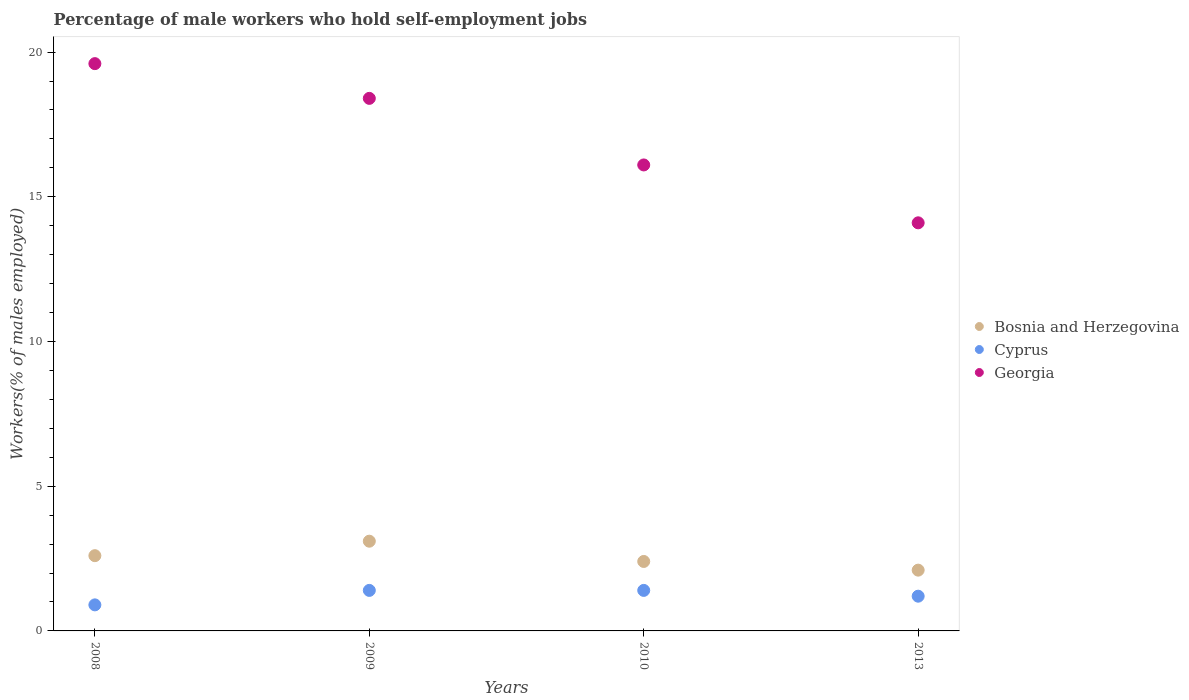How many different coloured dotlines are there?
Keep it short and to the point. 3. What is the percentage of self-employed male workers in Georgia in 2013?
Provide a short and direct response. 14.1. Across all years, what is the maximum percentage of self-employed male workers in Bosnia and Herzegovina?
Offer a terse response. 3.1. Across all years, what is the minimum percentage of self-employed male workers in Bosnia and Herzegovina?
Give a very brief answer. 2.1. In which year was the percentage of self-employed male workers in Georgia maximum?
Give a very brief answer. 2008. In which year was the percentage of self-employed male workers in Cyprus minimum?
Your answer should be very brief. 2008. What is the total percentage of self-employed male workers in Cyprus in the graph?
Your answer should be very brief. 4.9. What is the difference between the percentage of self-employed male workers in Georgia in 2009 and that in 2013?
Keep it short and to the point. 4.3. What is the difference between the percentage of self-employed male workers in Georgia in 2013 and the percentage of self-employed male workers in Bosnia and Herzegovina in 2010?
Make the answer very short. 11.7. What is the average percentage of self-employed male workers in Cyprus per year?
Your answer should be very brief. 1.22. In the year 2008, what is the difference between the percentage of self-employed male workers in Bosnia and Herzegovina and percentage of self-employed male workers in Georgia?
Make the answer very short. -17. In how many years, is the percentage of self-employed male workers in Bosnia and Herzegovina greater than 18 %?
Offer a terse response. 0. What is the ratio of the percentage of self-employed male workers in Georgia in 2009 to that in 2013?
Your response must be concise. 1.3. Is the difference between the percentage of self-employed male workers in Bosnia and Herzegovina in 2008 and 2009 greater than the difference between the percentage of self-employed male workers in Georgia in 2008 and 2009?
Give a very brief answer. No. What is the difference between the highest and the second highest percentage of self-employed male workers in Cyprus?
Keep it short and to the point. 0. What is the difference between the highest and the lowest percentage of self-employed male workers in Georgia?
Your answer should be compact. 5.5. In how many years, is the percentage of self-employed male workers in Georgia greater than the average percentage of self-employed male workers in Georgia taken over all years?
Your answer should be compact. 2. Is it the case that in every year, the sum of the percentage of self-employed male workers in Georgia and percentage of self-employed male workers in Bosnia and Herzegovina  is greater than the percentage of self-employed male workers in Cyprus?
Ensure brevity in your answer.  Yes. Does the percentage of self-employed male workers in Bosnia and Herzegovina monotonically increase over the years?
Make the answer very short. No. Is the percentage of self-employed male workers in Cyprus strictly greater than the percentage of self-employed male workers in Georgia over the years?
Give a very brief answer. No. Is the percentage of self-employed male workers in Bosnia and Herzegovina strictly less than the percentage of self-employed male workers in Cyprus over the years?
Give a very brief answer. No. How many years are there in the graph?
Provide a succinct answer. 4. Does the graph contain any zero values?
Offer a very short reply. No. How many legend labels are there?
Provide a short and direct response. 3. How are the legend labels stacked?
Keep it short and to the point. Vertical. What is the title of the graph?
Your response must be concise. Percentage of male workers who hold self-employment jobs. What is the label or title of the X-axis?
Your response must be concise. Years. What is the label or title of the Y-axis?
Provide a short and direct response. Workers(% of males employed). What is the Workers(% of males employed) in Bosnia and Herzegovina in 2008?
Your answer should be very brief. 2.6. What is the Workers(% of males employed) of Cyprus in 2008?
Make the answer very short. 0.9. What is the Workers(% of males employed) in Georgia in 2008?
Your response must be concise. 19.6. What is the Workers(% of males employed) in Bosnia and Herzegovina in 2009?
Your response must be concise. 3.1. What is the Workers(% of males employed) in Cyprus in 2009?
Make the answer very short. 1.4. What is the Workers(% of males employed) of Georgia in 2009?
Make the answer very short. 18.4. What is the Workers(% of males employed) of Bosnia and Herzegovina in 2010?
Provide a succinct answer. 2.4. What is the Workers(% of males employed) of Cyprus in 2010?
Your answer should be very brief. 1.4. What is the Workers(% of males employed) of Georgia in 2010?
Your response must be concise. 16.1. What is the Workers(% of males employed) in Bosnia and Herzegovina in 2013?
Provide a short and direct response. 2.1. What is the Workers(% of males employed) of Cyprus in 2013?
Make the answer very short. 1.2. What is the Workers(% of males employed) of Georgia in 2013?
Provide a succinct answer. 14.1. Across all years, what is the maximum Workers(% of males employed) in Bosnia and Herzegovina?
Your answer should be compact. 3.1. Across all years, what is the maximum Workers(% of males employed) in Cyprus?
Ensure brevity in your answer.  1.4. Across all years, what is the maximum Workers(% of males employed) of Georgia?
Offer a terse response. 19.6. Across all years, what is the minimum Workers(% of males employed) in Bosnia and Herzegovina?
Your answer should be very brief. 2.1. Across all years, what is the minimum Workers(% of males employed) of Cyprus?
Ensure brevity in your answer.  0.9. Across all years, what is the minimum Workers(% of males employed) of Georgia?
Provide a short and direct response. 14.1. What is the total Workers(% of males employed) in Georgia in the graph?
Make the answer very short. 68.2. What is the difference between the Workers(% of males employed) of Bosnia and Herzegovina in 2008 and that in 2009?
Provide a succinct answer. -0.5. What is the difference between the Workers(% of males employed) in Cyprus in 2008 and that in 2010?
Your response must be concise. -0.5. What is the difference between the Workers(% of males employed) of Bosnia and Herzegovina in 2008 and that in 2013?
Provide a succinct answer. 0.5. What is the difference between the Workers(% of males employed) in Cyprus in 2008 and that in 2013?
Your answer should be compact. -0.3. What is the difference between the Workers(% of males employed) in Georgia in 2008 and that in 2013?
Make the answer very short. 5.5. What is the difference between the Workers(% of males employed) in Bosnia and Herzegovina in 2009 and that in 2010?
Ensure brevity in your answer.  0.7. What is the difference between the Workers(% of males employed) of Cyprus in 2009 and that in 2013?
Give a very brief answer. 0.2. What is the difference between the Workers(% of males employed) of Georgia in 2009 and that in 2013?
Offer a terse response. 4.3. What is the difference between the Workers(% of males employed) in Bosnia and Herzegovina in 2010 and that in 2013?
Make the answer very short. 0.3. What is the difference between the Workers(% of males employed) in Cyprus in 2010 and that in 2013?
Your answer should be very brief. 0.2. What is the difference between the Workers(% of males employed) of Bosnia and Herzegovina in 2008 and the Workers(% of males employed) of Georgia in 2009?
Ensure brevity in your answer.  -15.8. What is the difference between the Workers(% of males employed) of Cyprus in 2008 and the Workers(% of males employed) of Georgia in 2009?
Offer a terse response. -17.5. What is the difference between the Workers(% of males employed) in Bosnia and Herzegovina in 2008 and the Workers(% of males employed) in Cyprus in 2010?
Your response must be concise. 1.2. What is the difference between the Workers(% of males employed) in Bosnia and Herzegovina in 2008 and the Workers(% of males employed) in Georgia in 2010?
Offer a very short reply. -13.5. What is the difference between the Workers(% of males employed) in Cyprus in 2008 and the Workers(% of males employed) in Georgia in 2010?
Offer a very short reply. -15.2. What is the difference between the Workers(% of males employed) in Cyprus in 2008 and the Workers(% of males employed) in Georgia in 2013?
Ensure brevity in your answer.  -13.2. What is the difference between the Workers(% of males employed) of Cyprus in 2009 and the Workers(% of males employed) of Georgia in 2010?
Provide a short and direct response. -14.7. What is the difference between the Workers(% of males employed) of Bosnia and Herzegovina in 2009 and the Workers(% of males employed) of Georgia in 2013?
Provide a short and direct response. -11. What is the difference between the Workers(% of males employed) in Bosnia and Herzegovina in 2010 and the Workers(% of males employed) in Cyprus in 2013?
Make the answer very short. 1.2. What is the difference between the Workers(% of males employed) in Bosnia and Herzegovina in 2010 and the Workers(% of males employed) in Georgia in 2013?
Offer a very short reply. -11.7. What is the average Workers(% of males employed) of Bosnia and Herzegovina per year?
Give a very brief answer. 2.55. What is the average Workers(% of males employed) in Cyprus per year?
Ensure brevity in your answer.  1.23. What is the average Workers(% of males employed) in Georgia per year?
Your answer should be very brief. 17.05. In the year 2008, what is the difference between the Workers(% of males employed) in Bosnia and Herzegovina and Workers(% of males employed) in Georgia?
Provide a short and direct response. -17. In the year 2008, what is the difference between the Workers(% of males employed) in Cyprus and Workers(% of males employed) in Georgia?
Provide a succinct answer. -18.7. In the year 2009, what is the difference between the Workers(% of males employed) of Bosnia and Herzegovina and Workers(% of males employed) of Cyprus?
Offer a very short reply. 1.7. In the year 2009, what is the difference between the Workers(% of males employed) of Bosnia and Herzegovina and Workers(% of males employed) of Georgia?
Keep it short and to the point. -15.3. In the year 2010, what is the difference between the Workers(% of males employed) in Bosnia and Herzegovina and Workers(% of males employed) in Cyprus?
Ensure brevity in your answer.  1. In the year 2010, what is the difference between the Workers(% of males employed) of Bosnia and Herzegovina and Workers(% of males employed) of Georgia?
Your response must be concise. -13.7. In the year 2010, what is the difference between the Workers(% of males employed) of Cyprus and Workers(% of males employed) of Georgia?
Provide a succinct answer. -14.7. In the year 2013, what is the difference between the Workers(% of males employed) in Bosnia and Herzegovina and Workers(% of males employed) in Cyprus?
Ensure brevity in your answer.  0.9. In the year 2013, what is the difference between the Workers(% of males employed) in Bosnia and Herzegovina and Workers(% of males employed) in Georgia?
Provide a succinct answer. -12. In the year 2013, what is the difference between the Workers(% of males employed) of Cyprus and Workers(% of males employed) of Georgia?
Make the answer very short. -12.9. What is the ratio of the Workers(% of males employed) in Bosnia and Herzegovina in 2008 to that in 2009?
Give a very brief answer. 0.84. What is the ratio of the Workers(% of males employed) in Cyprus in 2008 to that in 2009?
Your answer should be compact. 0.64. What is the ratio of the Workers(% of males employed) of Georgia in 2008 to that in 2009?
Keep it short and to the point. 1.07. What is the ratio of the Workers(% of males employed) in Cyprus in 2008 to that in 2010?
Your answer should be very brief. 0.64. What is the ratio of the Workers(% of males employed) of Georgia in 2008 to that in 2010?
Ensure brevity in your answer.  1.22. What is the ratio of the Workers(% of males employed) of Bosnia and Herzegovina in 2008 to that in 2013?
Your response must be concise. 1.24. What is the ratio of the Workers(% of males employed) of Georgia in 2008 to that in 2013?
Provide a short and direct response. 1.39. What is the ratio of the Workers(% of males employed) in Bosnia and Herzegovina in 2009 to that in 2010?
Make the answer very short. 1.29. What is the ratio of the Workers(% of males employed) of Cyprus in 2009 to that in 2010?
Give a very brief answer. 1. What is the ratio of the Workers(% of males employed) of Bosnia and Herzegovina in 2009 to that in 2013?
Offer a terse response. 1.48. What is the ratio of the Workers(% of males employed) of Cyprus in 2009 to that in 2013?
Your answer should be very brief. 1.17. What is the ratio of the Workers(% of males employed) in Georgia in 2009 to that in 2013?
Ensure brevity in your answer.  1.3. What is the ratio of the Workers(% of males employed) of Georgia in 2010 to that in 2013?
Offer a very short reply. 1.14. What is the difference between the highest and the second highest Workers(% of males employed) of Bosnia and Herzegovina?
Provide a short and direct response. 0.5. What is the difference between the highest and the second highest Workers(% of males employed) of Georgia?
Ensure brevity in your answer.  1.2. What is the difference between the highest and the lowest Workers(% of males employed) of Cyprus?
Ensure brevity in your answer.  0.5. What is the difference between the highest and the lowest Workers(% of males employed) in Georgia?
Offer a terse response. 5.5. 